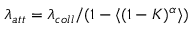Convert formula to latex. <formula><loc_0><loc_0><loc_500><loc_500>\lambda _ { a t t } = \lambda _ { c o l l } / ( 1 - \langle ( 1 - K ) ^ { \alpha } \rangle )</formula> 